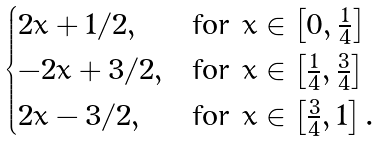Convert formula to latex. <formula><loc_0><loc_0><loc_500><loc_500>\begin{cases} 2 x + 1 / 2 , & \text {for} \ x \in \left [ 0 , \frac { 1 } { 4 } \right ] \\ - 2 x + 3 / 2 , & \text {for} \ x \in \left [ \frac { 1 } { 4 } , \frac { 3 } { 4 } \right ] \\ 2 x - 3 / 2 , & \text {for} \ x \in \left [ \frac { 3 } { 4 } , 1 \right ] . \end{cases}</formula> 